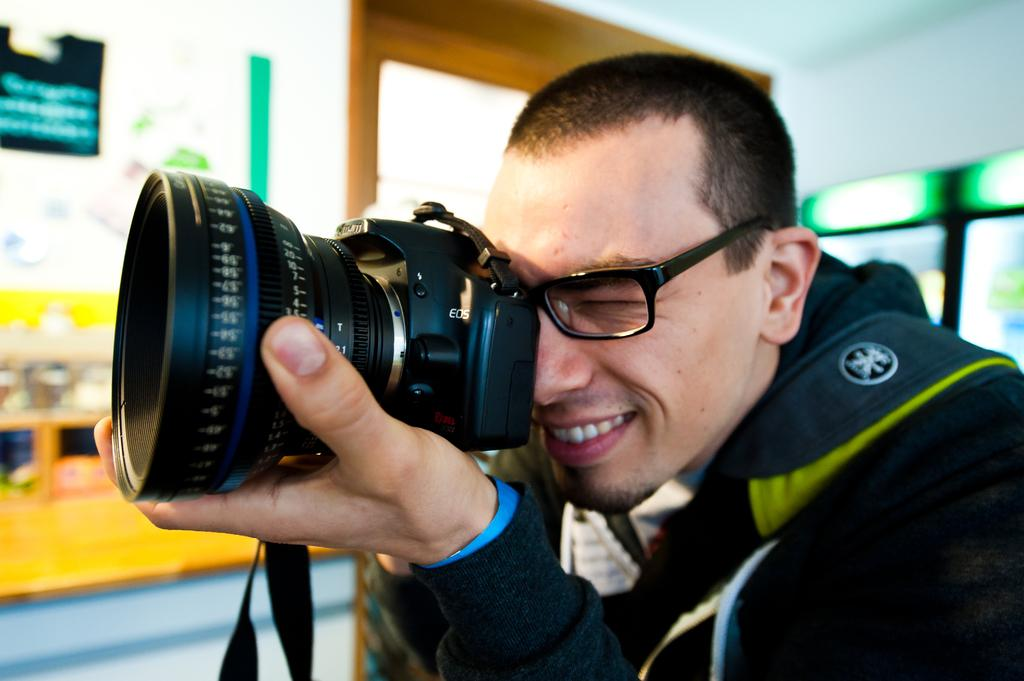Who is present in the image? There is a person in the image. What is the person wearing? The person is wearing a black jacket. What is the person holding in his hand? The person is holding a camera in his hand. How many mice can be seen running around the person's feet in the image? There are no mice present in the image. What type of class is the person attending in the image? There is no indication of a class or any educational setting in the image. 